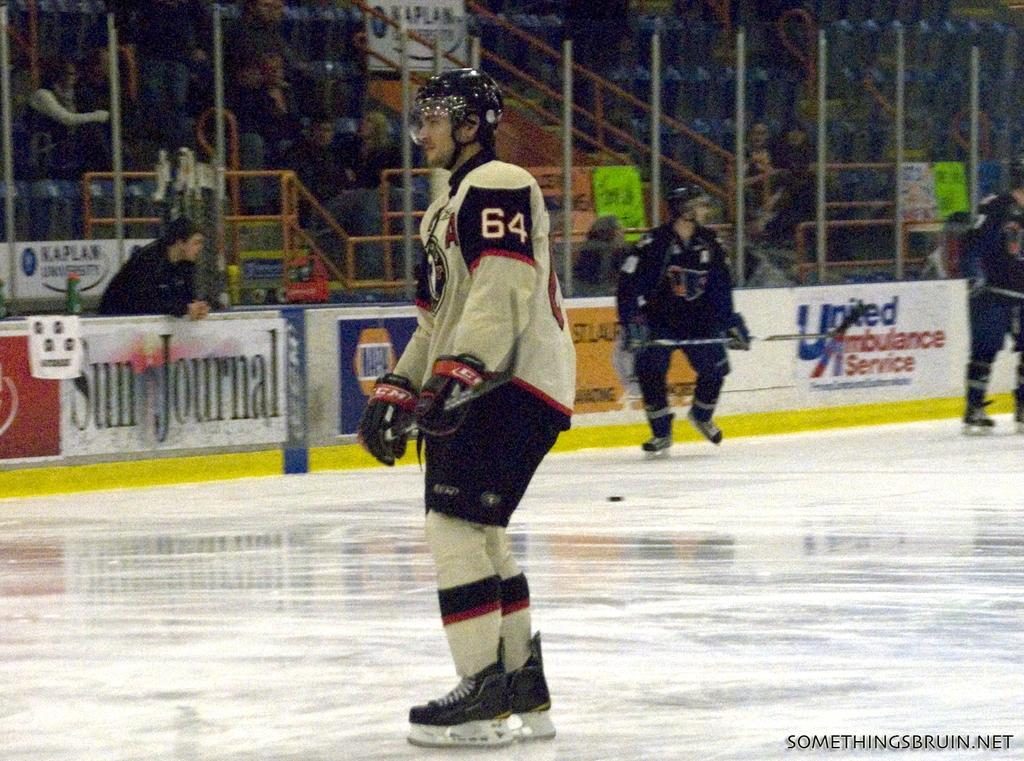<image>
Relay a brief, clear account of the picture shown. A hockey player wearing jersey 64 stands on the ice during a game. 